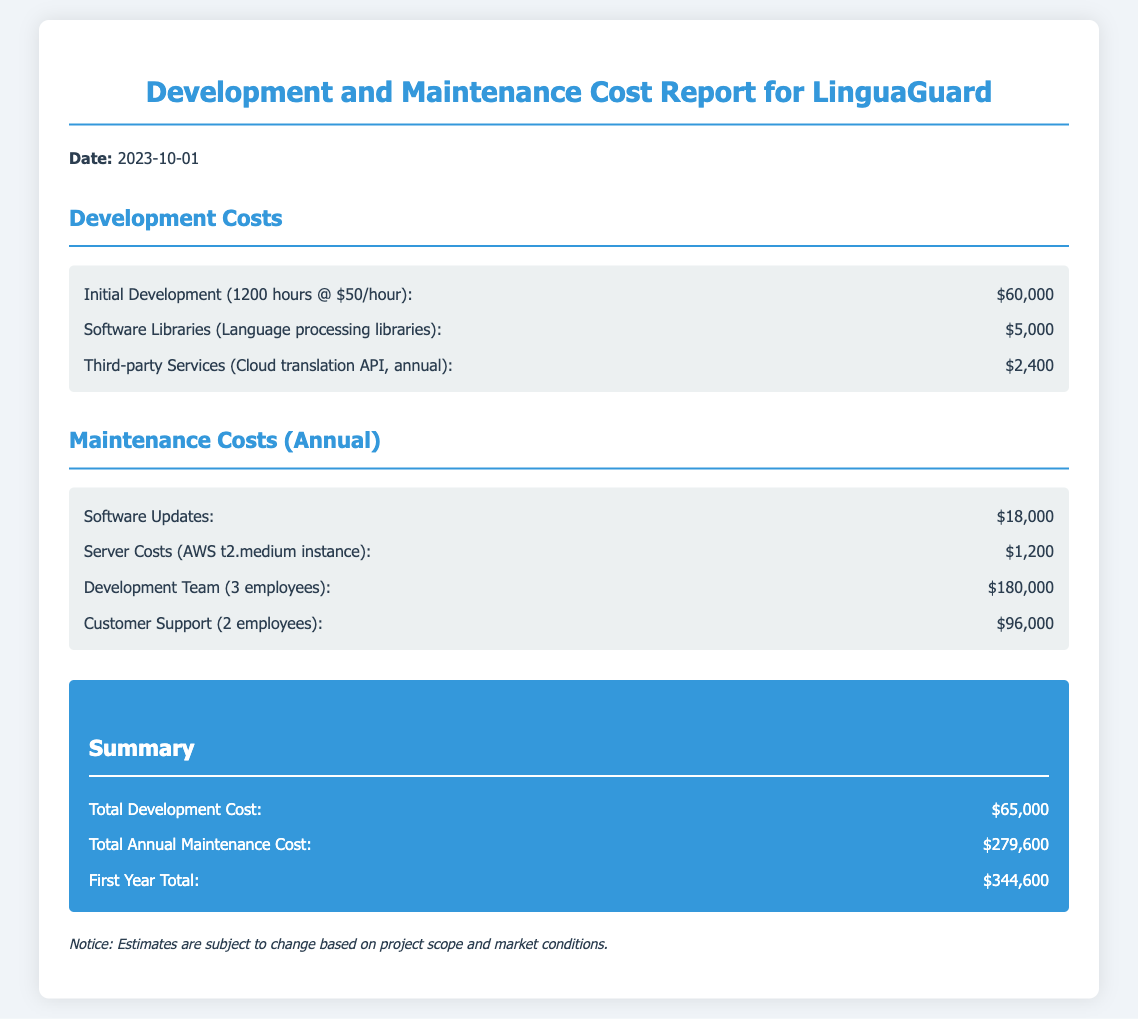What is the date of the report? The report date is explicitly mentioned at the beginning of the document as 2023-10-01.
Answer: 2023-10-01 What is the cost for software updates? The cost for software updates is detailed in the maintenance costs section of the document, which lists it as $18,000.
Answer: $18,000 How many employees are in the development team? The number of employees in the development team is stated as 3 employees.
Answer: 3 employees What is the total development cost? The total development cost is calculated and mentioned as $65,000 in the summary section.
Answer: $65,000 What is the total annual maintenance cost? The total annual maintenance cost is explicitly stated in the summary as $279,600.
Answer: $279,600 What is the total cost for customer support? The document specifies that the cost for customer support (2 employees) is $96,000.
Answer: $96,000 What is the duration of initial development stated in hours? The initial development duration is mentioned as 1200 hours.
Answer: 1200 hours What is the total first year cost? The first year total cost is clearly summarized and listed as $344,600.
Answer: $344,600 What type of server is mentioned for server costs? The type of server mentioned for server costs is an AWS t2.medium instance.
Answer: AWS t2.medium instance 